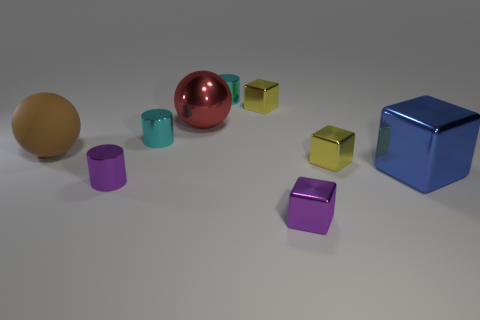Is the number of big blocks less than the number of cyan matte cylinders?
Offer a terse response. No. What is the shape of the object that is both to the right of the tiny purple cube and left of the big blue object?
Provide a short and direct response. Cube. What number of red things are there?
Your response must be concise. 1. What is the material of the purple thing that is on the left side of the tiny cyan metal cylinder that is behind the shiny cube that is behind the big red thing?
Offer a very short reply. Metal. How many brown rubber spheres are behind the big blue shiny block that is to the right of the red ball?
Provide a short and direct response. 1. There is another matte thing that is the same shape as the big red thing; what color is it?
Your answer should be compact. Brown. Are the red sphere and the brown thing made of the same material?
Provide a succinct answer. No. How many cubes are either large red objects or big cyan matte things?
Provide a short and direct response. 0. There is a red shiny object to the right of the sphere in front of the large shiny sphere that is behind the big brown matte object; what size is it?
Ensure brevity in your answer.  Large. What size is the other object that is the same shape as the brown thing?
Your answer should be very brief. Large. 